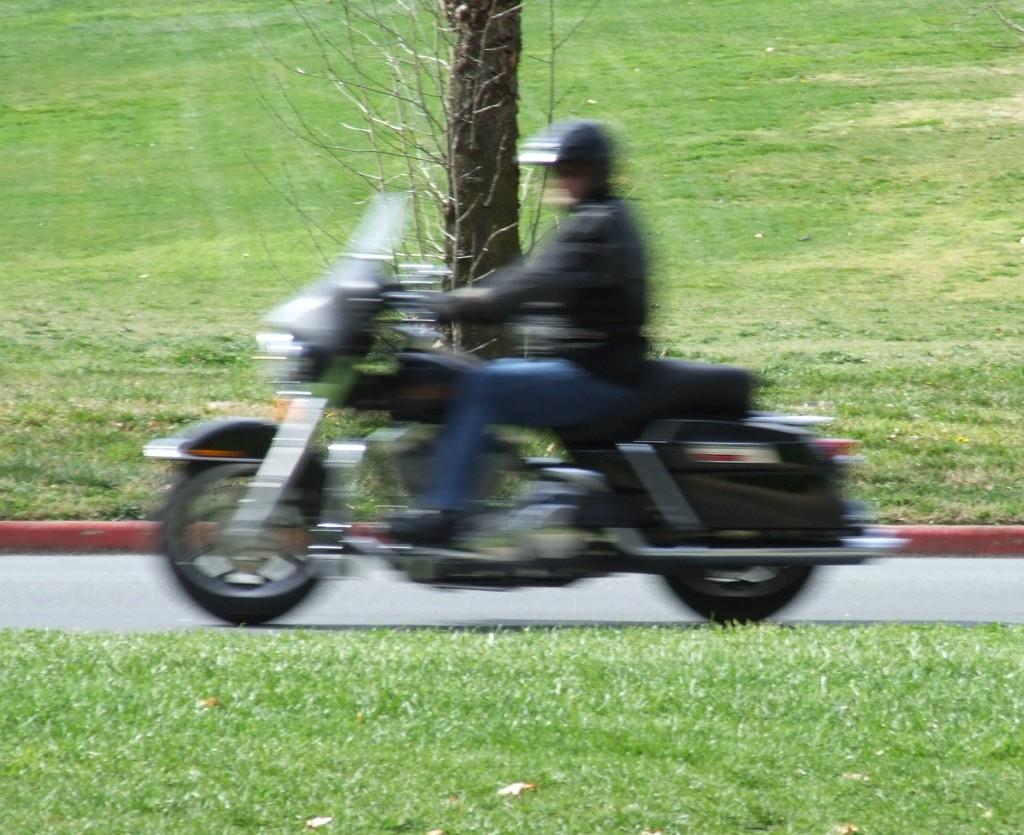Who is the main subject in the image? There is a man in the image. What is the man doing in the image? The man is riding a motorbike. Can you describe the appearance of the motorbike? The motorbike appears slightly blurred in the image. What can be seen in the background of the image? There is a tree visible in the background of the image. What type of punishment is the man receiving for riding the motorbike in the image? There is no indication of punishment in the image; the man is simply riding a motorbike. What is the man using to write on the tree in the background of the image? There is no man writing on a tree in the image, nor is there a quill present. 